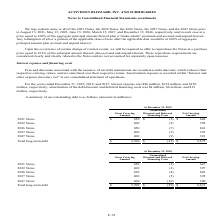According to Activision Blizzard's financial document, What were fees and discounts associated with the issuance of the company's debt instruments recorded as? debt discount, which reduces their respective carrying values, and are amortized over their respective terms.. The document states: "e issuance of our debt instruments are recorded as debt discount, which reduces their respective carrying values, and are amortized over their respect..." Also, What was the interest expense for 2019? According to the financial document, $86 million. The relevant text states: "ber 31, 2019, 2018, and 2017: interest expense was $86 million, $134 million, and $150..." Also, What was the interest expense for 2018? According to the financial document, $134 million. The relevant text states: "2018, and 2017: interest expense was $86 million, $134 million, and $150..." Also, can you calculate: What was the change in the gross carrying amount between the 2021 and 2022 Notes in 2019? Based on the calculation: 400-650, the result is -250 (in millions). This is based on the information: "2022 Notes 400 (2) 398 2021 Notes $ 650 $ (2) $ 648..." The key data points involved are: 400, 650. Also, can you calculate: What was the change in the net carrying amount between the 2026 and 2027 Notes in 2018? Based on the calculation: 395-842, the result is -447 (in millions). This is based on the information: "2026 Notes 850 (8) 842 2027 Notes 400 (5) 395..." The key data points involved are: 395, 842. Also, can you calculate: What was the percentage change in the net carrying amount of total long-term debt between 2018 and 2019? To answer this question, I need to perform calculations using the financial data. The calculation is: ($2,675-$2,671)/$2,671, which equals 0.15 (percentage). This is based on the information: "Total long-term debt $ 2,700 $ (25) $ 2,675 Total long-term debt $ 2,700 $ (29) $ 2,671..." The key data points involved are: 2,671, 2,675. 